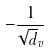Convert formula to latex. <formula><loc_0><loc_0><loc_500><loc_500>- \frac { 1 } { \sqrt { d } _ { v } }</formula> 